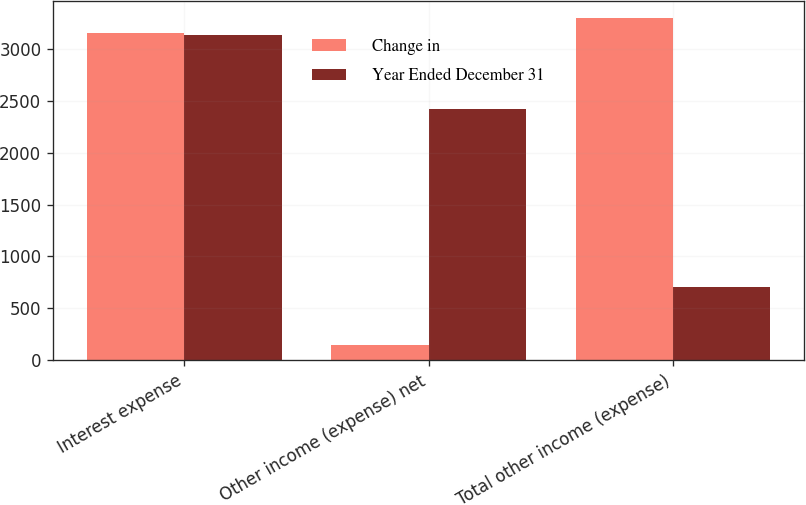Convert chart to OTSL. <chart><loc_0><loc_0><loc_500><loc_500><stacked_bar_chart><ecel><fcel>Interest expense<fcel>Other income (expense) net<fcel>Total other income (expense)<nl><fcel>Change in<fcel>3152<fcel>147<fcel>3299<nl><fcel>Year Ended December 31<fcel>3128<fcel>2422<fcel>706<nl></chart> 